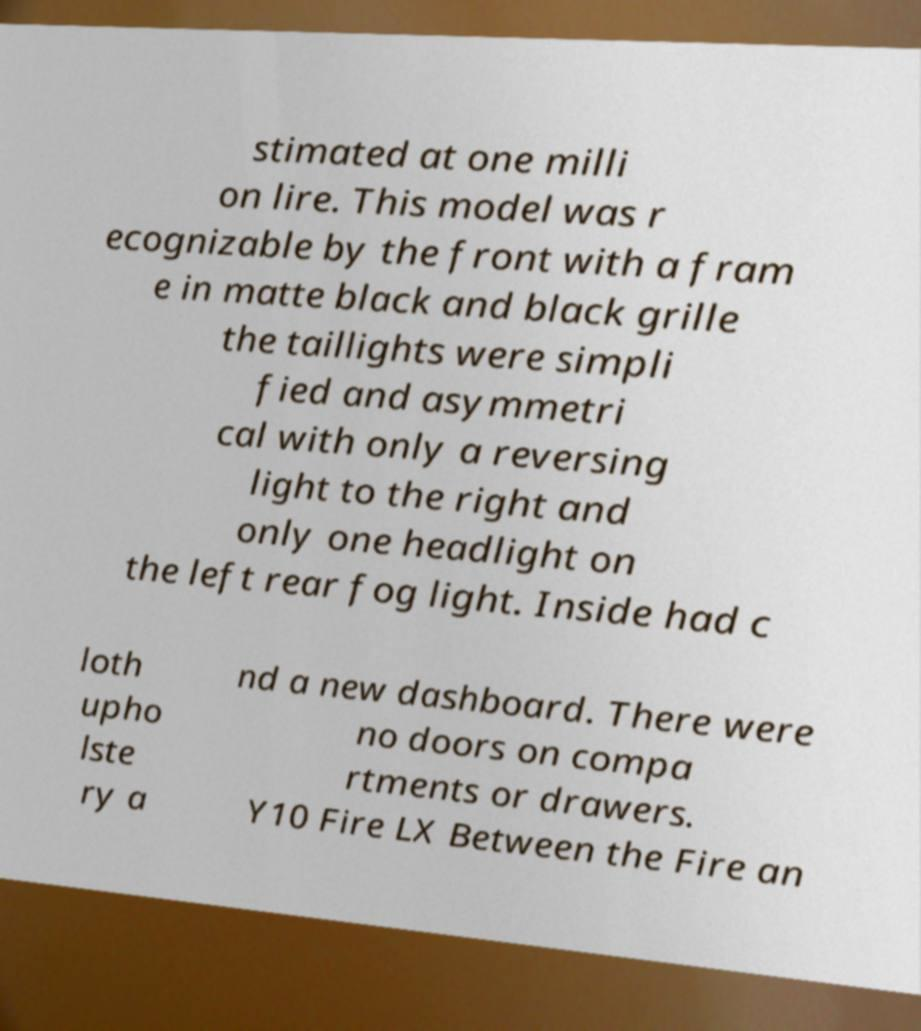There's text embedded in this image that I need extracted. Can you transcribe it verbatim? stimated at one milli on lire. This model was r ecognizable by the front with a fram e in matte black and black grille the taillights were simpli fied and asymmetri cal with only a reversing light to the right and only one headlight on the left rear fog light. Inside had c loth upho lste ry a nd a new dashboard. There were no doors on compa rtments or drawers. Y10 Fire LX Between the Fire an 